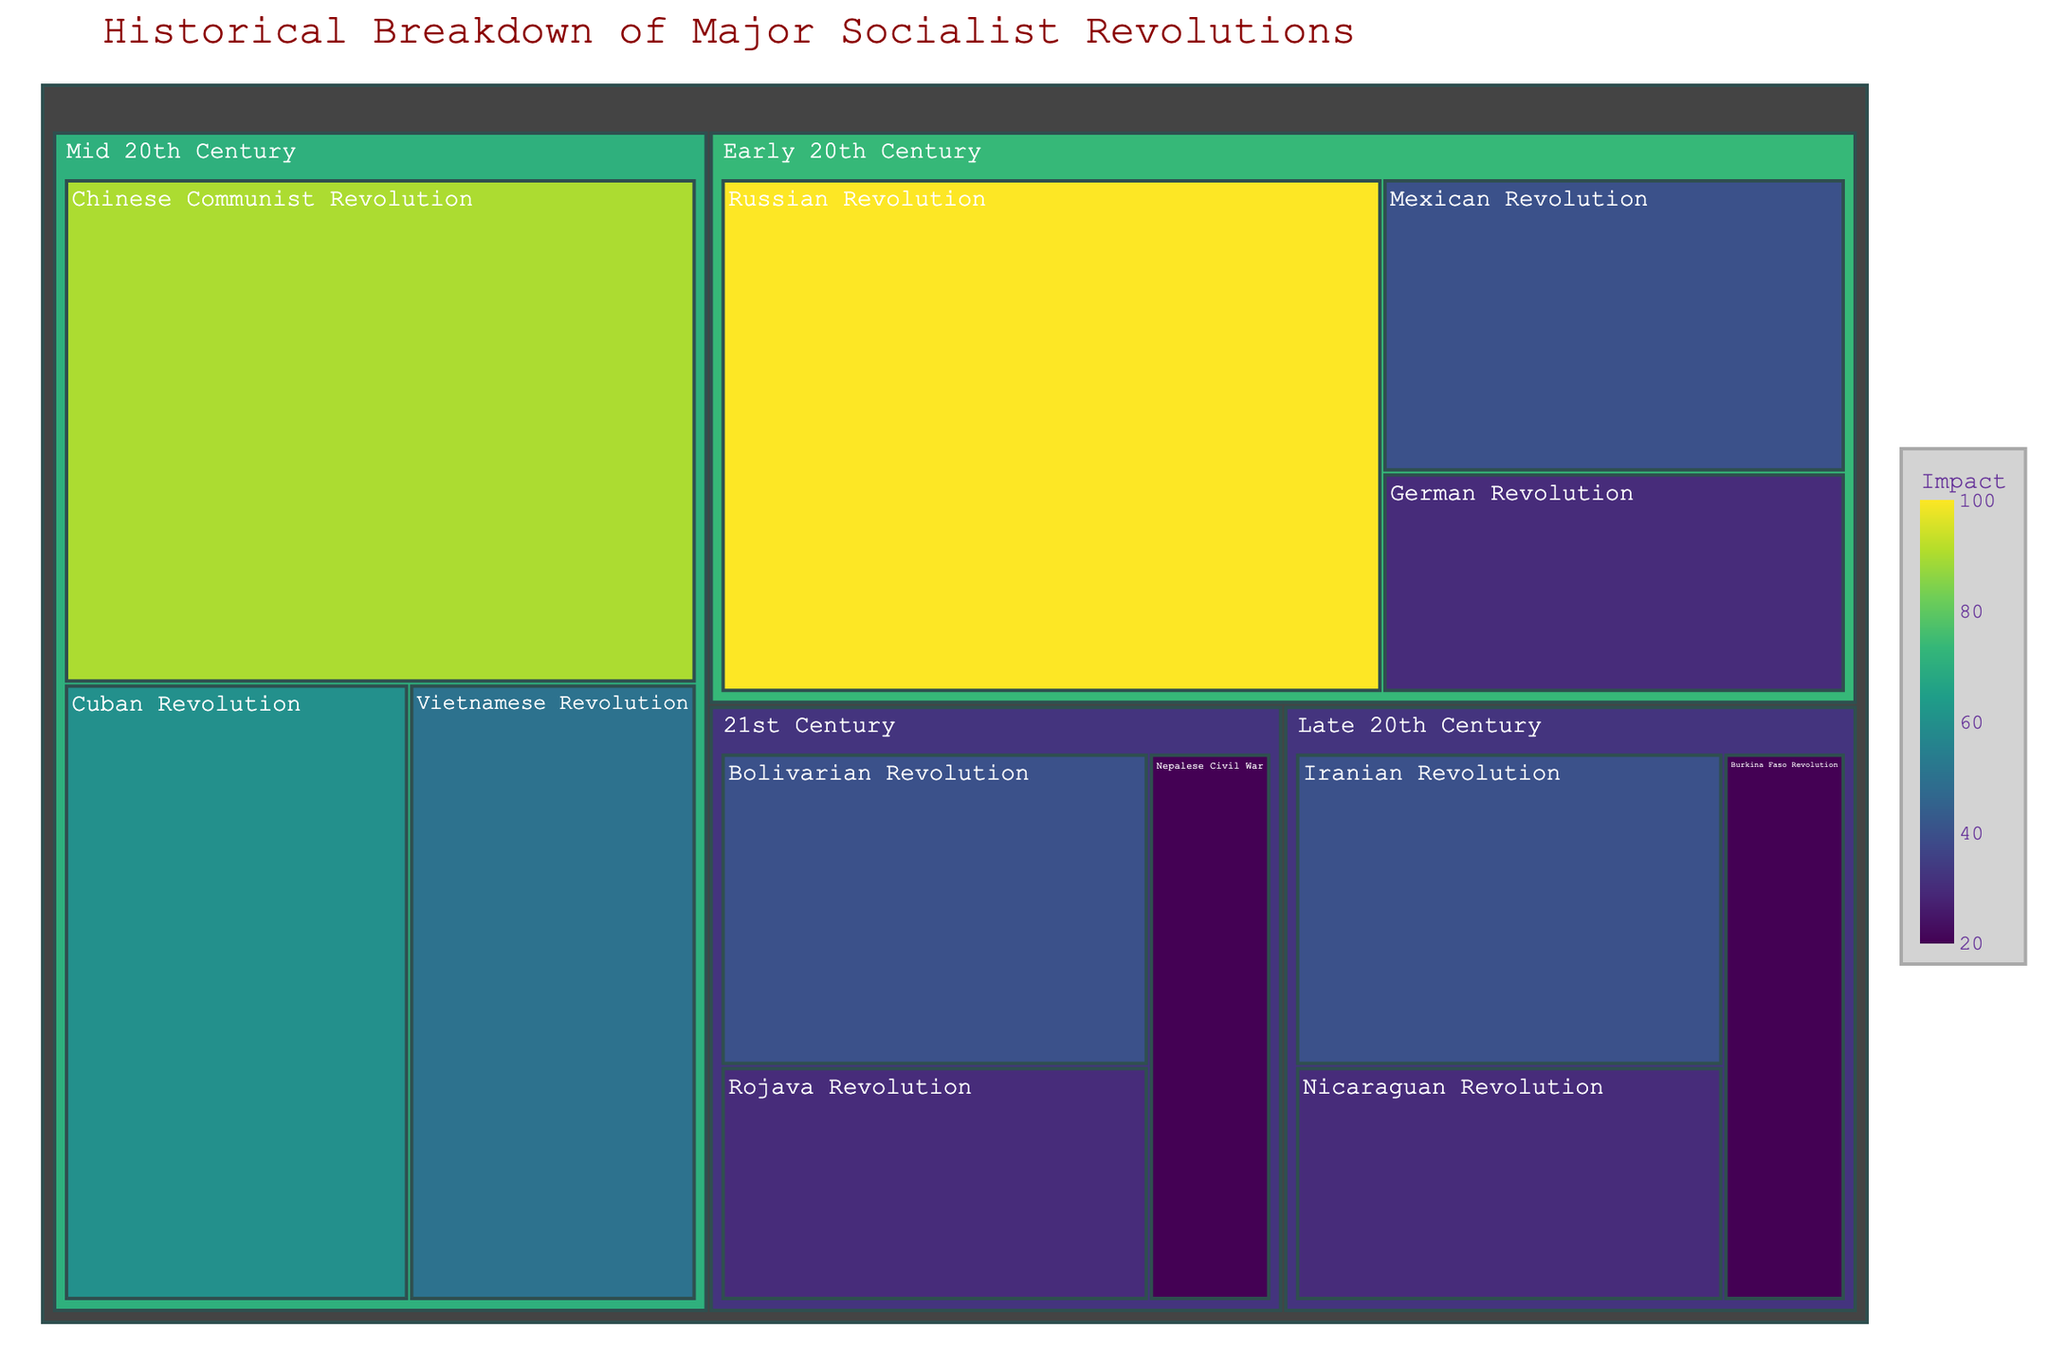Which revolution in the Early 20th Century had the highest impact? To find the revolution with the highest impact in the Early 20th Century, look for the largest block in that category. The Russian Revolution has a value of 100, which is the highest.
Answer: Russian Revolution What color represents the highest impact on the treemap? The highest impact value (100) is colored with the darkest shade of the Viridis colormap.
Answer: Dark Green How many revolutions are displayed in the Mid 20th Century period? Count the number of blocks in the Mid 20th Century category. There are three: Chinese Communist Revolution, Cuban Revolution, and Vietnamese Revolution.
Answer: 3 Which revolution had the smallest impact in the Late 20th Century? Identify the revolution with the smallest block in the Late 20th Century category. The Burkina Faso Revolution has the smallest value of 20.
Answer: Burkina Faso Revolution Compare the impact of the Mexican Revolution to the Cuban Revolution. Which had a greater impact? Check the impact values for both revolutions. The Mexican Revolution has an impact of 40, while the Cuban Revolution has an impact of 60. Therefore, the Cuban Revolution had a greater impact.
Answer: Cuban Revolution What is the total impact of the revolutions in the 21st Century? Add the impact values of all revolutions in the 21st Century: Bolivarian Revolution (40), Nepalese Civil War (20), and Rojava Revolution (30). The sum is 90.
Answer: 90 Which time period contains the revolution with the maximum impact? Identify the time period of the revolution with the highest impact value, which is the Russian Revolution (100). The period is Early 20th Century.
Answer: Early 20th Century How does the impact of the Nicaraguan Revolution compare to that of the Bolivarian Revolution? Compare the impact values of both revolutions. The Nicaraguan Revolution has an impact of 30, while the Bolivarian Revolution has an impact of 40. The Bolivarian Revolution had a greater impact.
Answer: Bolivarian Revolution What is the average impact of all revolutions in the treemap? Sum the impact values of all revolutions and divide by the number of revolutions. The total impact is 460, and there are 12 revolutions. The average impact is 460 / 12 ≈ 38.33.
Answer: 38.33 Which revolution in the treemap has a similar impact to the Iranian Revolution? Look for a revolution with an impact value close to the Iranian Revolution's impact of 40. The Mexican Revolution and Bolivarian Revolution both have an impact of 40.
Answer: Mexican Revolution, Bolivarian Revolution 